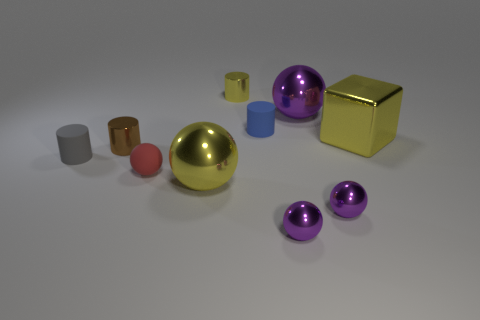What time of day does this scene represent? The scene appears to be in a controlled indoor environment without direct indicators of a specific time of day. 